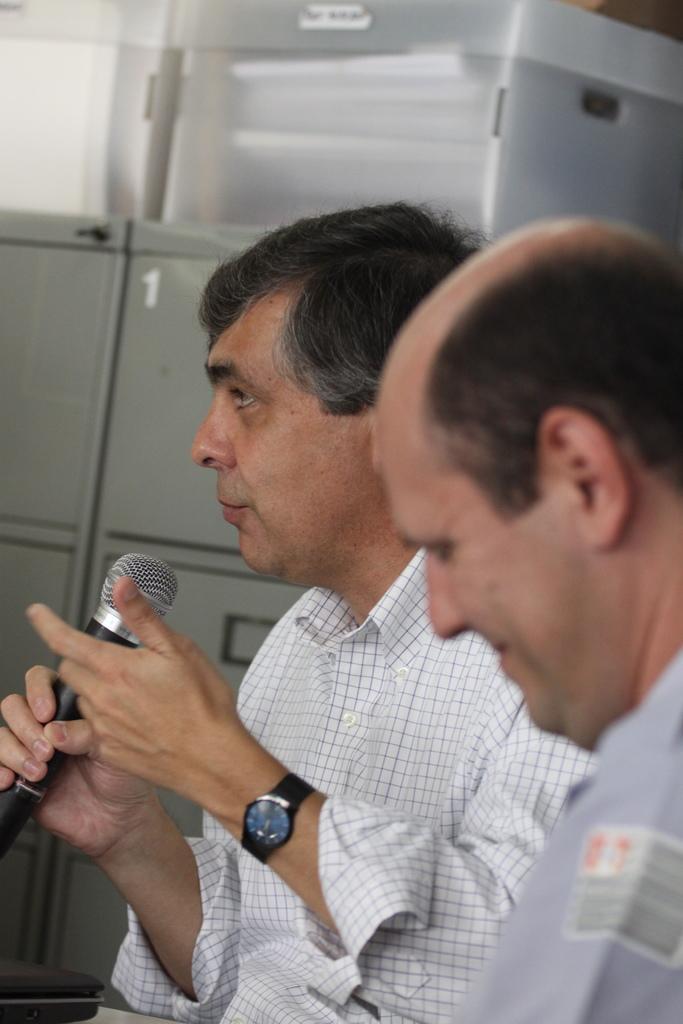Please provide a concise description of this image. In this image we can see two persons and among them a man is holding a mic in his hands. In the background we can see pages in a plastic boxes on the metal locker boxes. 